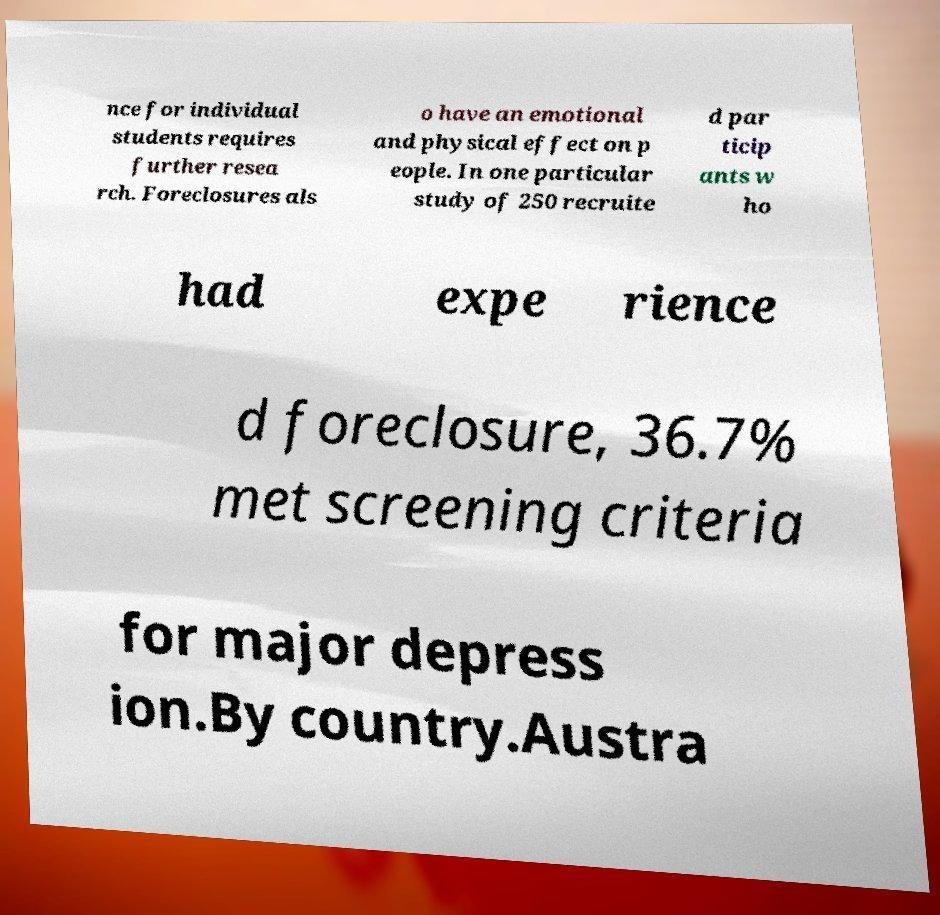There's text embedded in this image that I need extracted. Can you transcribe it verbatim? nce for individual students requires further resea rch. Foreclosures als o have an emotional and physical effect on p eople. In one particular study of 250 recruite d par ticip ants w ho had expe rience d foreclosure, 36.7% met screening criteria for major depress ion.By country.Austra 